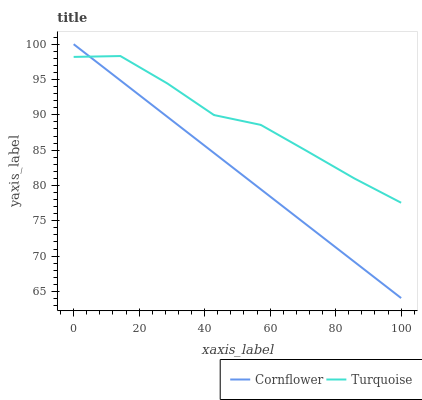Does Cornflower have the minimum area under the curve?
Answer yes or no. Yes. Does Turquoise have the maximum area under the curve?
Answer yes or no. Yes. Does Turquoise have the minimum area under the curve?
Answer yes or no. No. Is Cornflower the smoothest?
Answer yes or no. Yes. Is Turquoise the roughest?
Answer yes or no. Yes. Is Turquoise the smoothest?
Answer yes or no. No. Does Cornflower have the lowest value?
Answer yes or no. Yes. Does Turquoise have the lowest value?
Answer yes or no. No. Does Cornflower have the highest value?
Answer yes or no. Yes. Does Turquoise have the highest value?
Answer yes or no. No. Does Cornflower intersect Turquoise?
Answer yes or no. Yes. Is Cornflower less than Turquoise?
Answer yes or no. No. Is Cornflower greater than Turquoise?
Answer yes or no. No. 